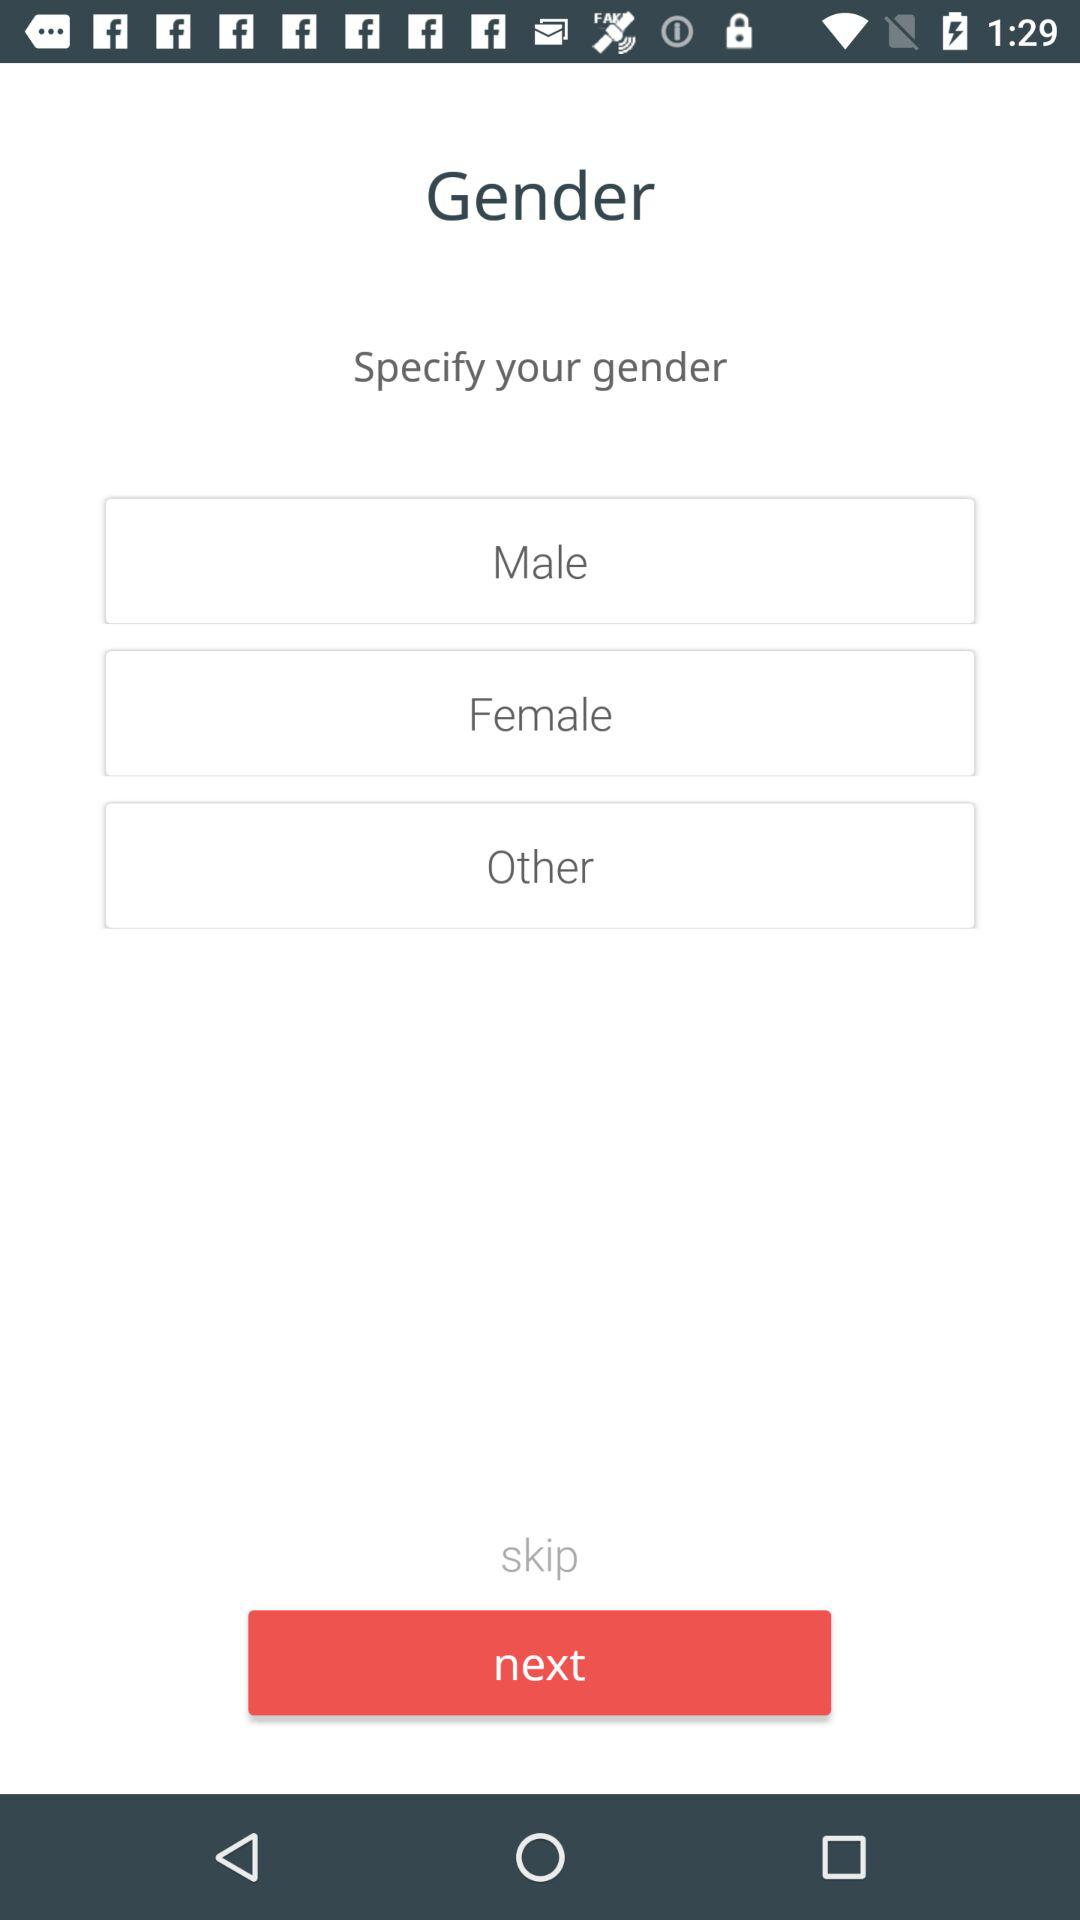What are the options for choosing a gender? The options for choosing a gender are "Male", "Female" and "Other". 